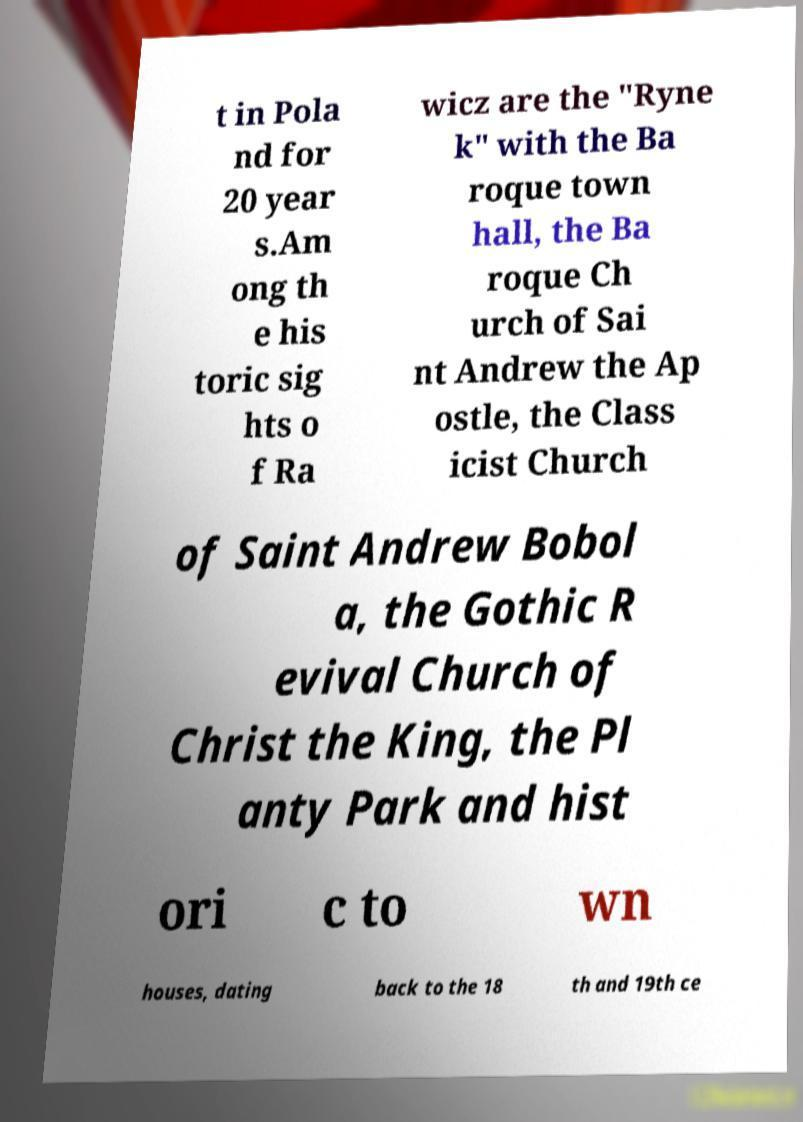What messages or text are displayed in this image? I need them in a readable, typed format. t in Pola nd for 20 year s.Am ong th e his toric sig hts o f Ra wicz are the "Ryne k" with the Ba roque town hall, the Ba roque Ch urch of Sai nt Andrew the Ap ostle, the Class icist Church of Saint Andrew Bobol a, the Gothic R evival Church of Christ the King, the Pl anty Park and hist ori c to wn houses, dating back to the 18 th and 19th ce 